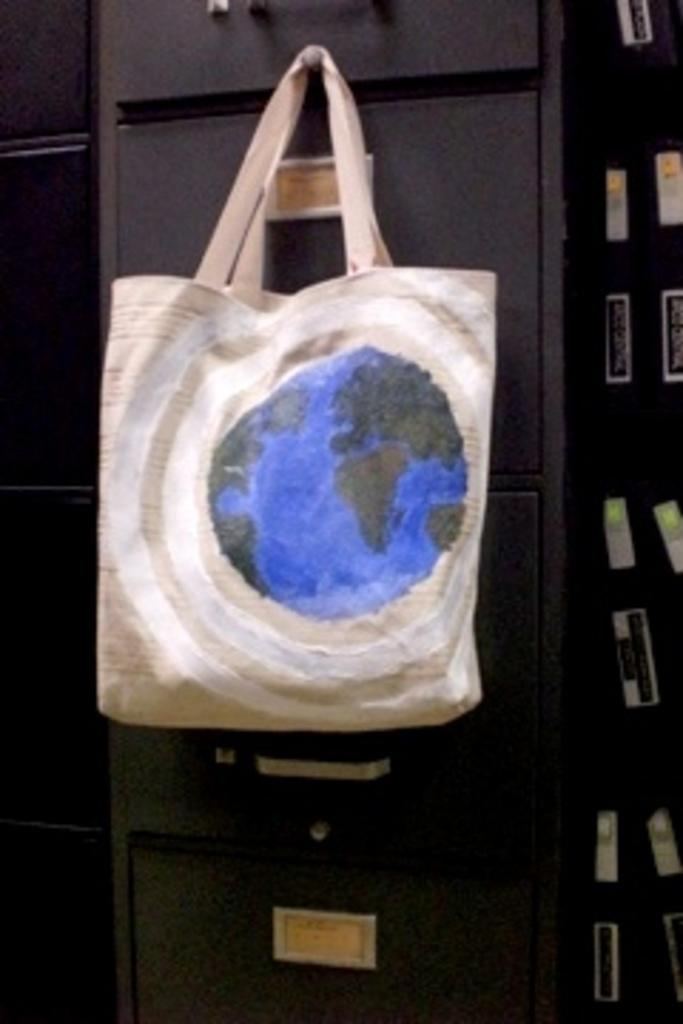What type of accessory is present in the image? There is a handbag in the image. What color is the handbag? The handbag is white in color. What type of fang can be seen in the image? There are no fangs present in the image; it features a white handbag. What type of beef is being cooked in the image? There is no beef or cooking activity present in the image. 